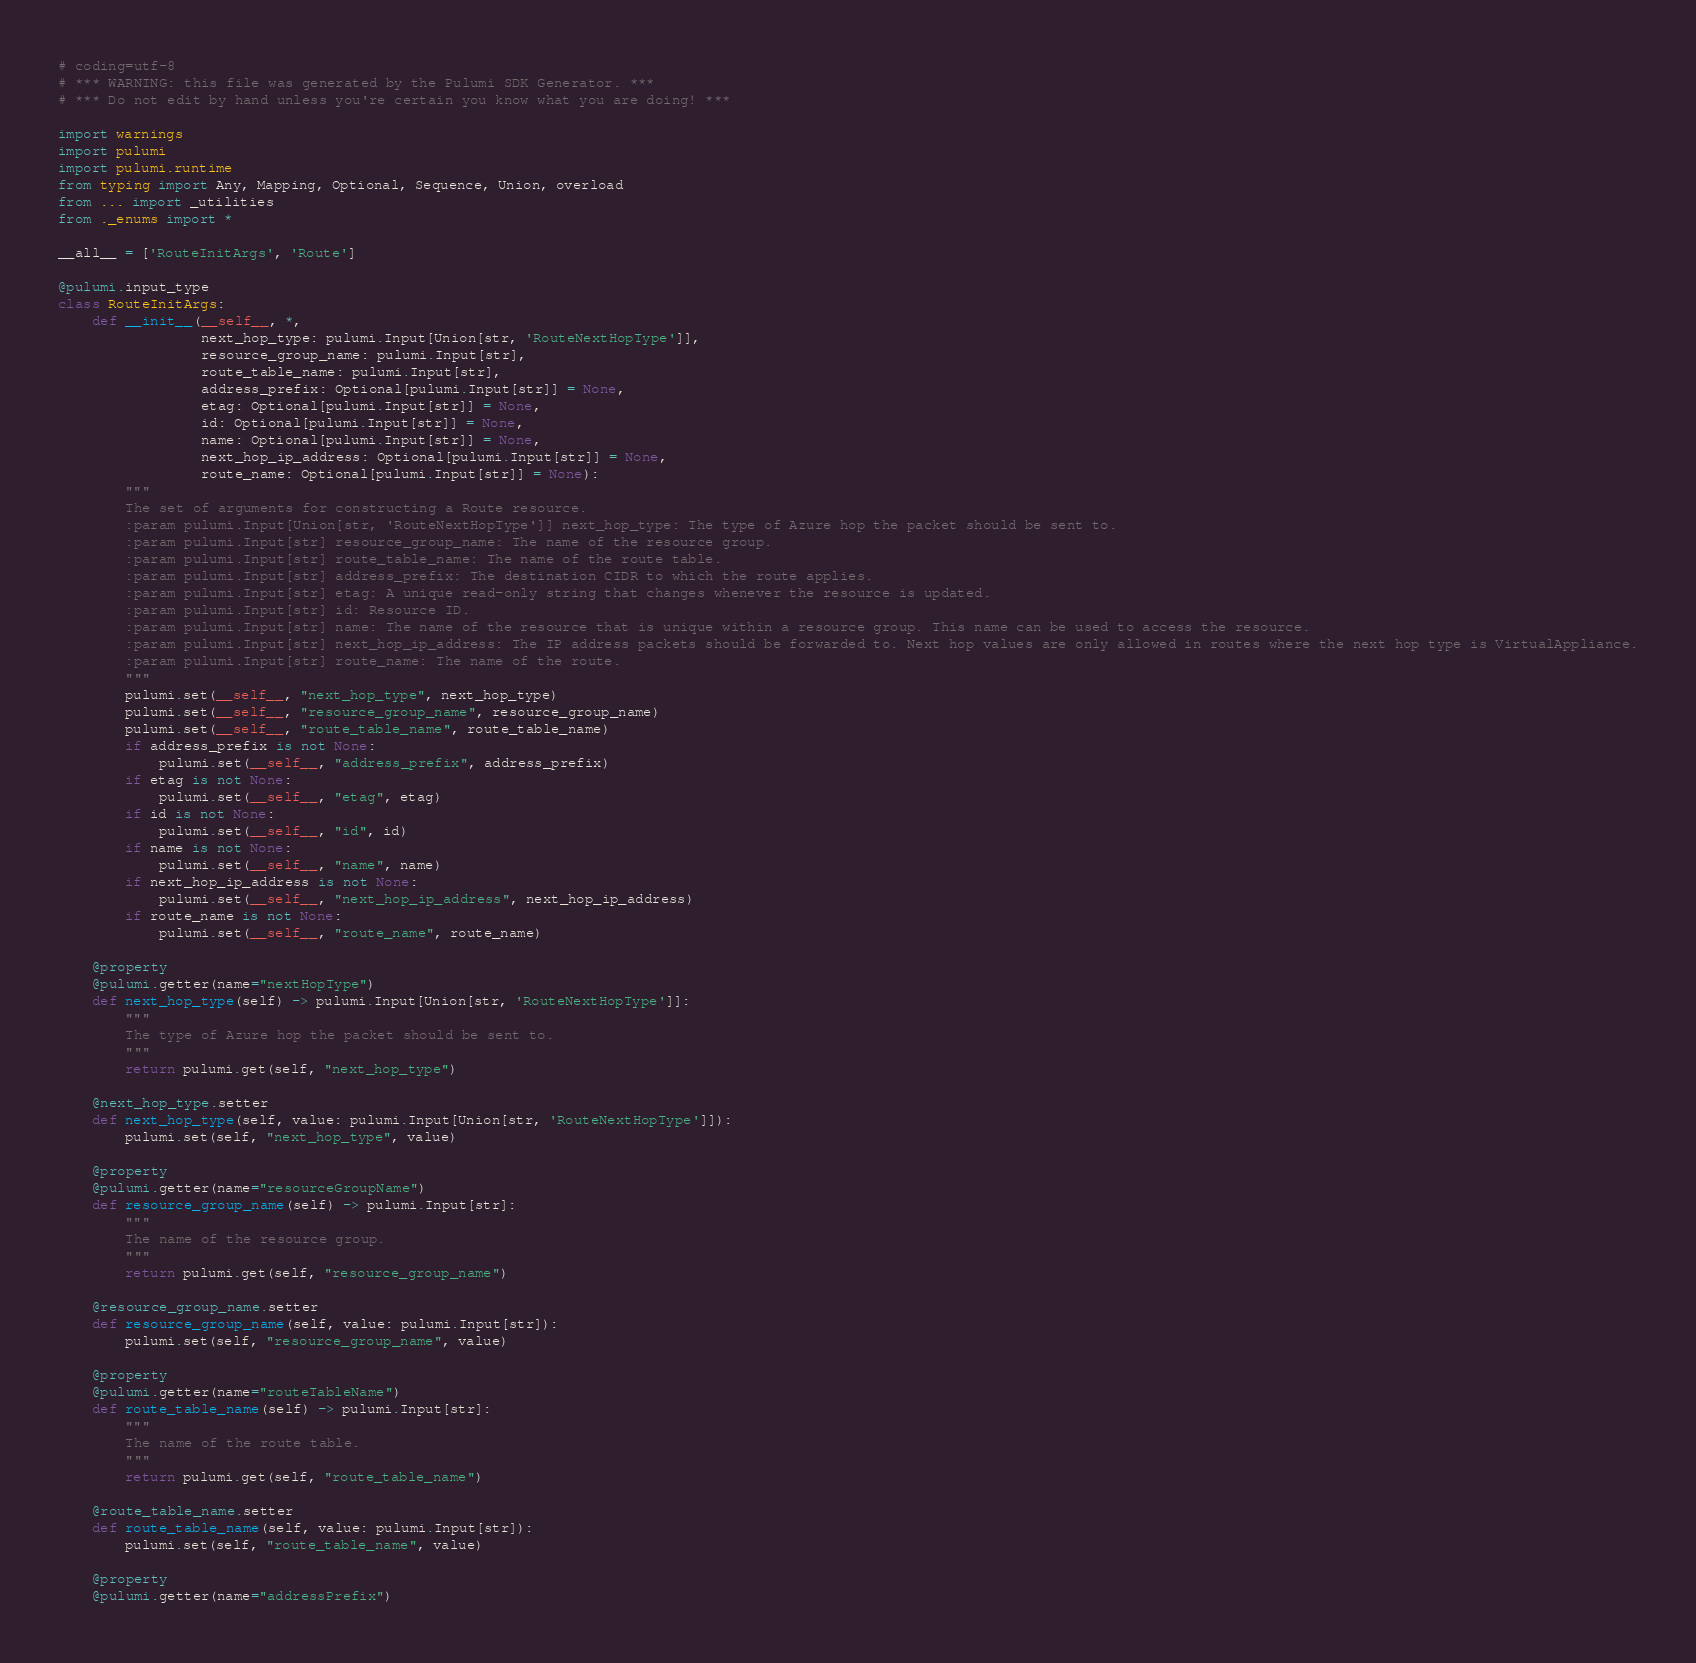<code> <loc_0><loc_0><loc_500><loc_500><_Python_># coding=utf-8
# *** WARNING: this file was generated by the Pulumi SDK Generator. ***
# *** Do not edit by hand unless you're certain you know what you are doing! ***

import warnings
import pulumi
import pulumi.runtime
from typing import Any, Mapping, Optional, Sequence, Union, overload
from ... import _utilities
from ._enums import *

__all__ = ['RouteInitArgs', 'Route']

@pulumi.input_type
class RouteInitArgs:
    def __init__(__self__, *,
                 next_hop_type: pulumi.Input[Union[str, 'RouteNextHopType']],
                 resource_group_name: pulumi.Input[str],
                 route_table_name: pulumi.Input[str],
                 address_prefix: Optional[pulumi.Input[str]] = None,
                 etag: Optional[pulumi.Input[str]] = None,
                 id: Optional[pulumi.Input[str]] = None,
                 name: Optional[pulumi.Input[str]] = None,
                 next_hop_ip_address: Optional[pulumi.Input[str]] = None,
                 route_name: Optional[pulumi.Input[str]] = None):
        """
        The set of arguments for constructing a Route resource.
        :param pulumi.Input[Union[str, 'RouteNextHopType']] next_hop_type: The type of Azure hop the packet should be sent to.
        :param pulumi.Input[str] resource_group_name: The name of the resource group.
        :param pulumi.Input[str] route_table_name: The name of the route table.
        :param pulumi.Input[str] address_prefix: The destination CIDR to which the route applies.
        :param pulumi.Input[str] etag: A unique read-only string that changes whenever the resource is updated.
        :param pulumi.Input[str] id: Resource ID.
        :param pulumi.Input[str] name: The name of the resource that is unique within a resource group. This name can be used to access the resource.
        :param pulumi.Input[str] next_hop_ip_address: The IP address packets should be forwarded to. Next hop values are only allowed in routes where the next hop type is VirtualAppliance.
        :param pulumi.Input[str] route_name: The name of the route.
        """
        pulumi.set(__self__, "next_hop_type", next_hop_type)
        pulumi.set(__self__, "resource_group_name", resource_group_name)
        pulumi.set(__self__, "route_table_name", route_table_name)
        if address_prefix is not None:
            pulumi.set(__self__, "address_prefix", address_prefix)
        if etag is not None:
            pulumi.set(__self__, "etag", etag)
        if id is not None:
            pulumi.set(__self__, "id", id)
        if name is not None:
            pulumi.set(__self__, "name", name)
        if next_hop_ip_address is not None:
            pulumi.set(__self__, "next_hop_ip_address", next_hop_ip_address)
        if route_name is not None:
            pulumi.set(__self__, "route_name", route_name)

    @property
    @pulumi.getter(name="nextHopType")
    def next_hop_type(self) -> pulumi.Input[Union[str, 'RouteNextHopType']]:
        """
        The type of Azure hop the packet should be sent to.
        """
        return pulumi.get(self, "next_hop_type")

    @next_hop_type.setter
    def next_hop_type(self, value: pulumi.Input[Union[str, 'RouteNextHopType']]):
        pulumi.set(self, "next_hop_type", value)

    @property
    @pulumi.getter(name="resourceGroupName")
    def resource_group_name(self) -> pulumi.Input[str]:
        """
        The name of the resource group.
        """
        return pulumi.get(self, "resource_group_name")

    @resource_group_name.setter
    def resource_group_name(self, value: pulumi.Input[str]):
        pulumi.set(self, "resource_group_name", value)

    @property
    @pulumi.getter(name="routeTableName")
    def route_table_name(self) -> pulumi.Input[str]:
        """
        The name of the route table.
        """
        return pulumi.get(self, "route_table_name")

    @route_table_name.setter
    def route_table_name(self, value: pulumi.Input[str]):
        pulumi.set(self, "route_table_name", value)

    @property
    @pulumi.getter(name="addressPrefix")</code> 